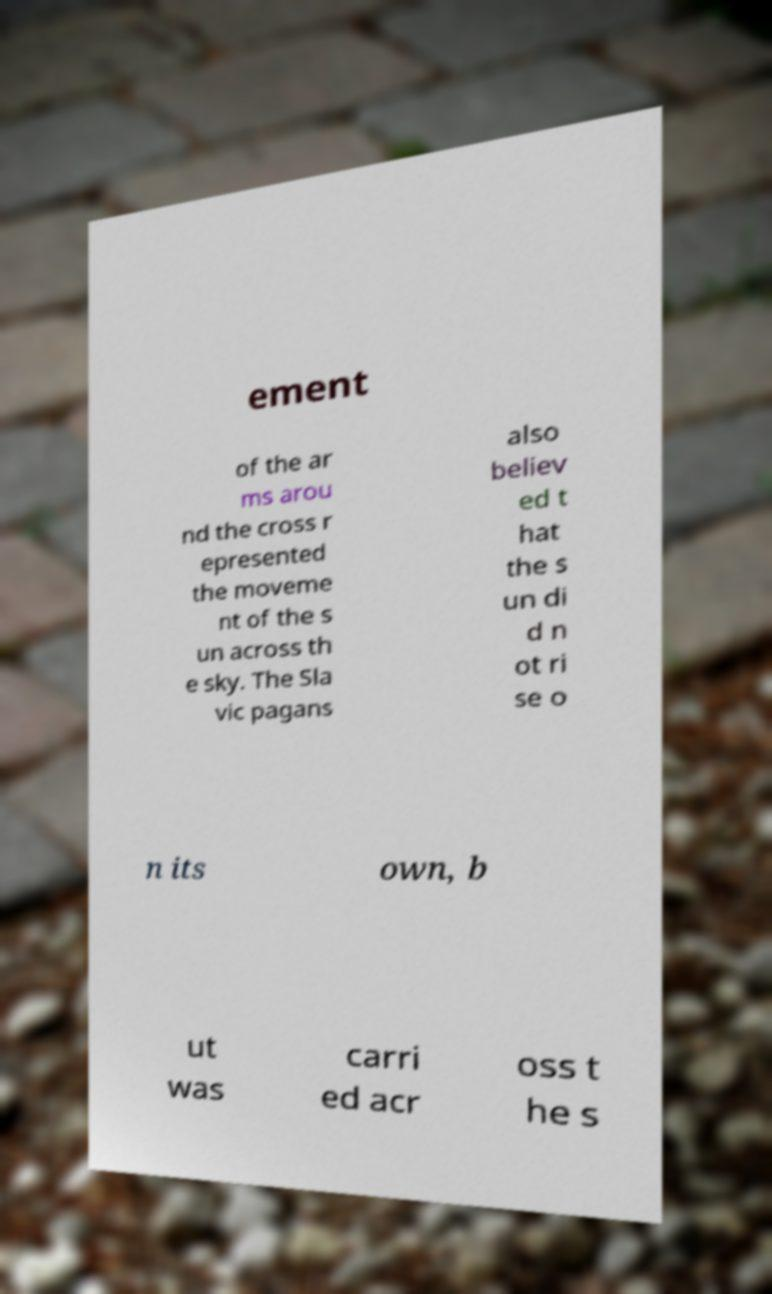Please identify and transcribe the text found in this image. ement of the ar ms arou nd the cross r epresented the moveme nt of the s un across th e sky. The Sla vic pagans also believ ed t hat the s un di d n ot ri se o n its own, b ut was carri ed acr oss t he s 